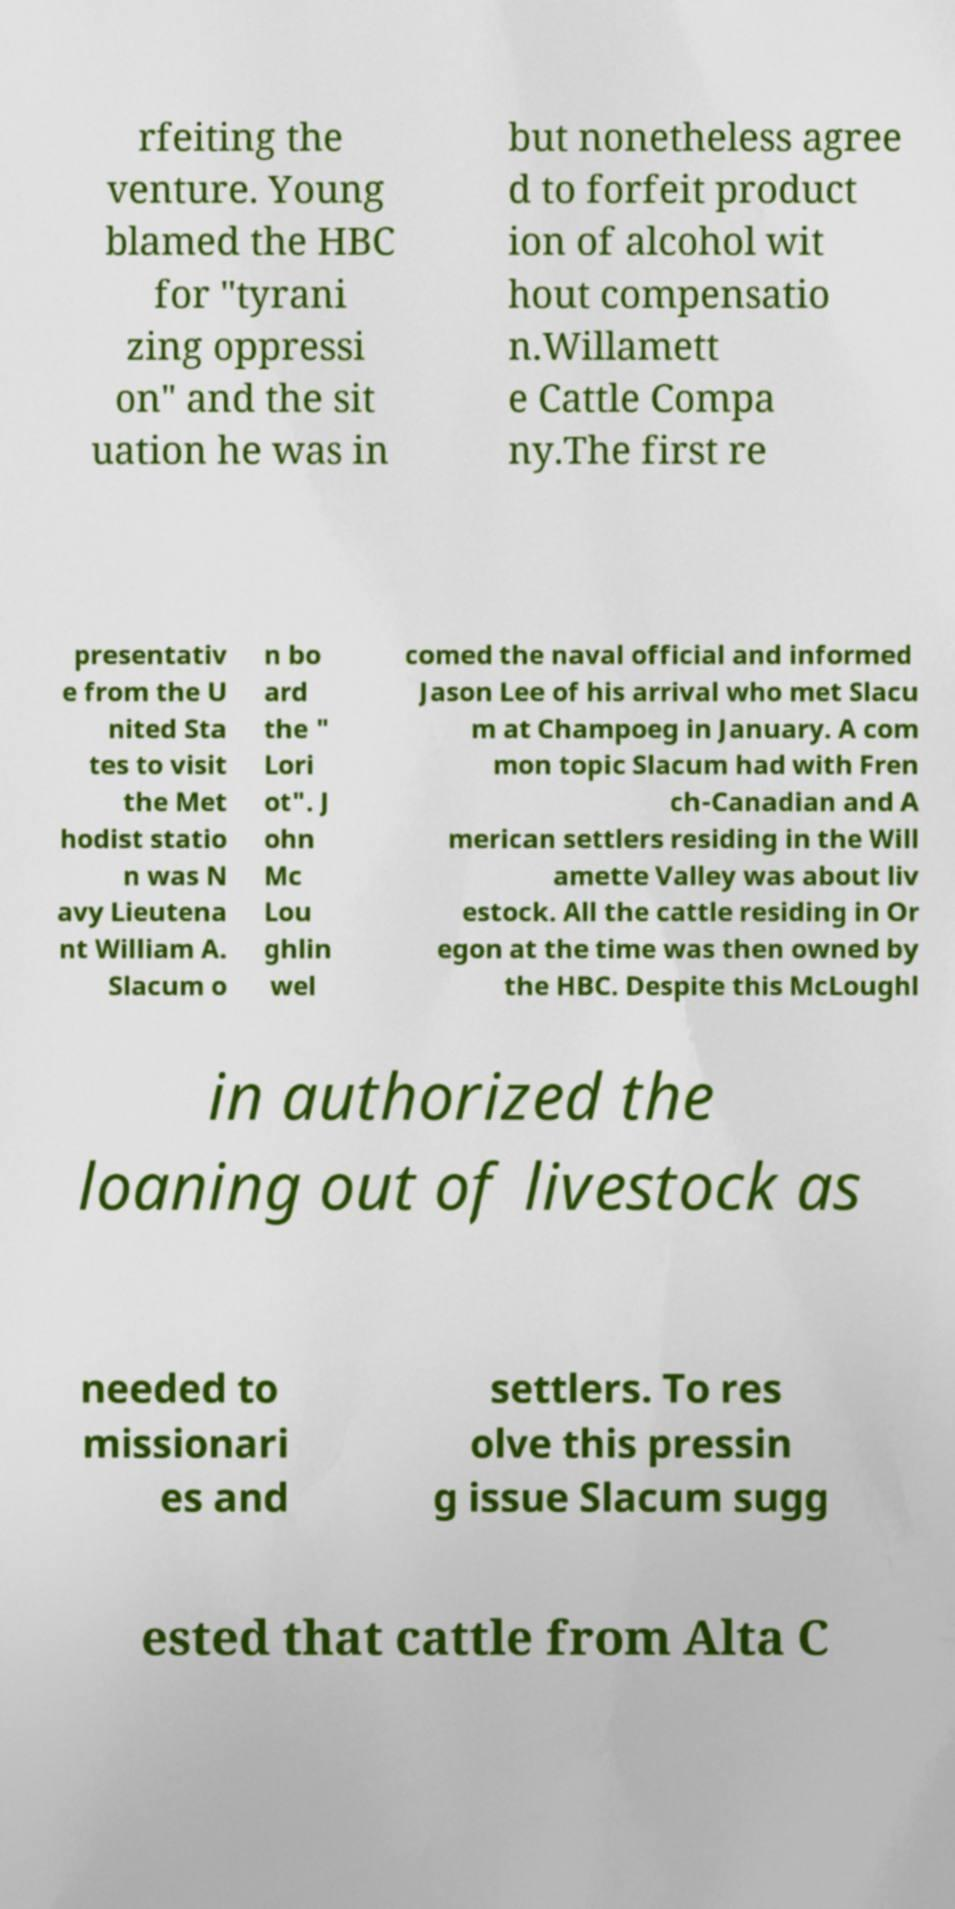Can you read and provide the text displayed in the image?This photo seems to have some interesting text. Can you extract and type it out for me? rfeiting the venture. Young blamed the HBC for "tyrani zing oppressi on" and the sit uation he was in but nonetheless agree d to forfeit product ion of alcohol wit hout compensatio n.Willamett e Cattle Compa ny.The first re presentativ e from the U nited Sta tes to visit the Met hodist statio n was N avy Lieutena nt William A. Slacum o n bo ard the " Lori ot". J ohn Mc Lou ghlin wel comed the naval official and informed Jason Lee of his arrival who met Slacu m at Champoeg in January. A com mon topic Slacum had with Fren ch-Canadian and A merican settlers residing in the Will amette Valley was about liv estock. All the cattle residing in Or egon at the time was then owned by the HBC. Despite this McLoughl in authorized the loaning out of livestock as needed to missionari es and settlers. To res olve this pressin g issue Slacum sugg ested that cattle from Alta C 